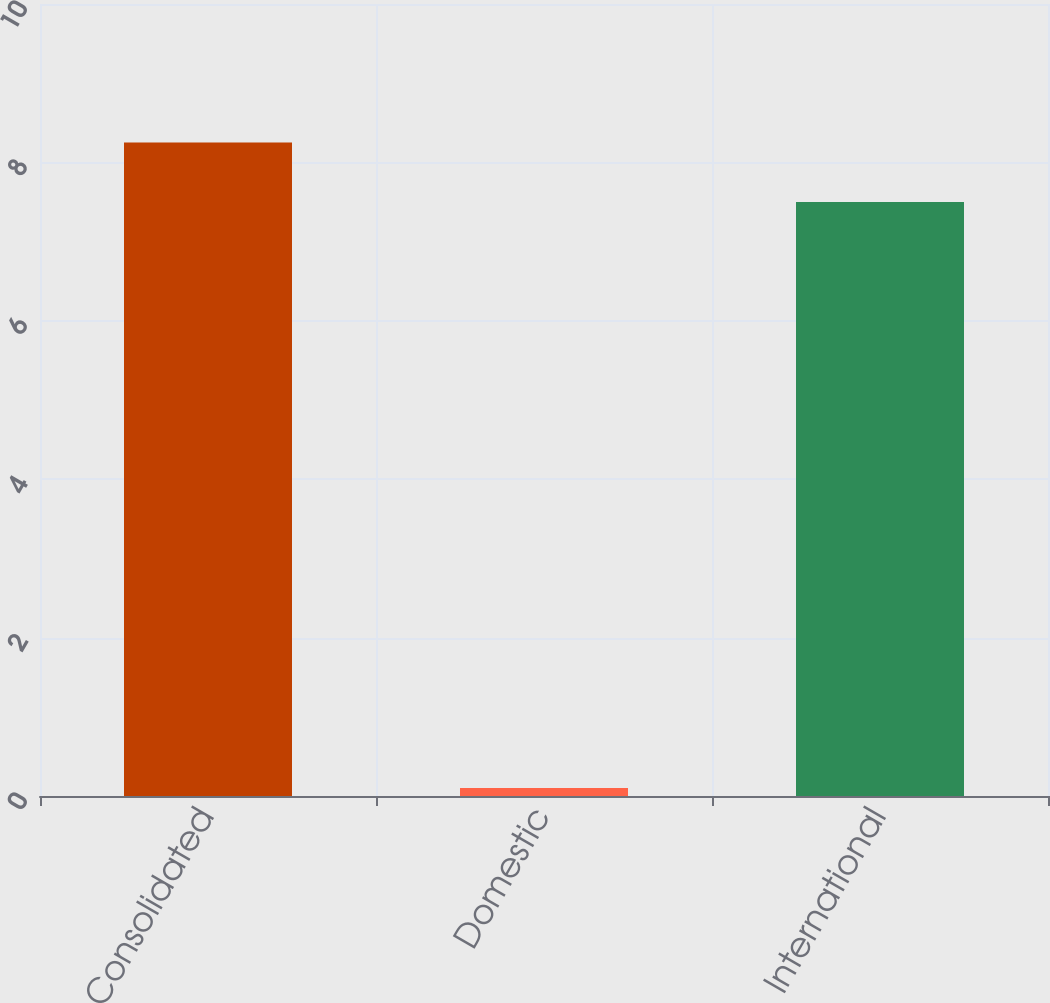<chart> <loc_0><loc_0><loc_500><loc_500><bar_chart><fcel>Consolidated<fcel>Domestic<fcel>International<nl><fcel>8.25<fcel>0.1<fcel>7.5<nl></chart> 